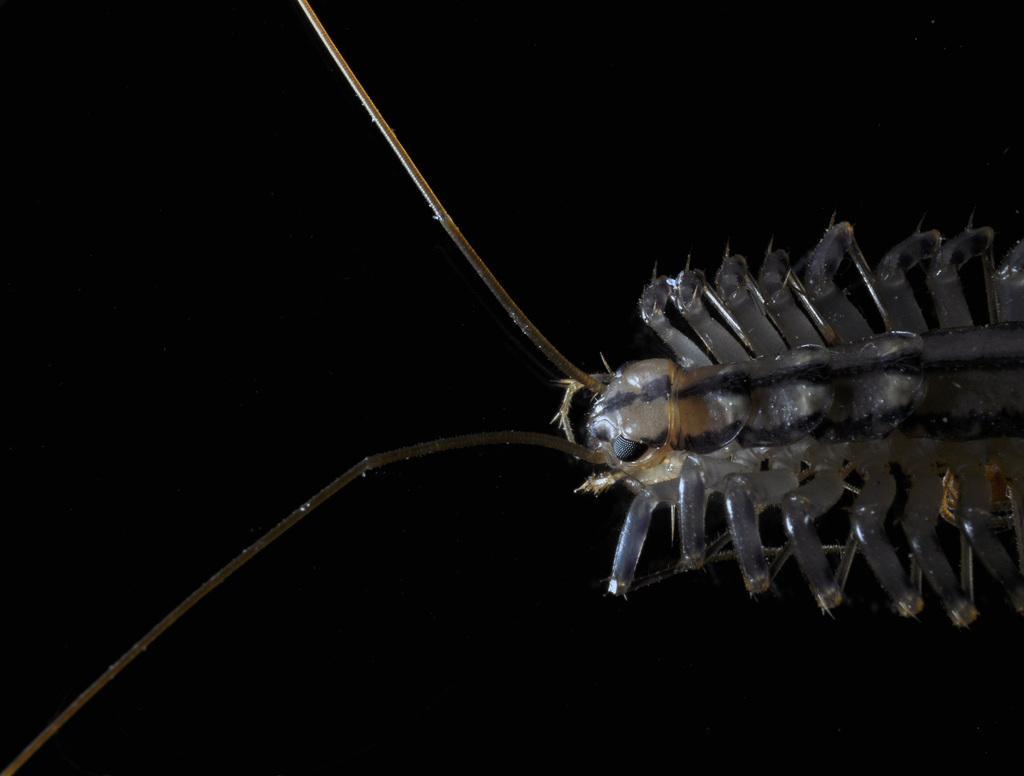Please provide a concise description of this image. In this picture we can see an insect and in the background we can see it is dark. 